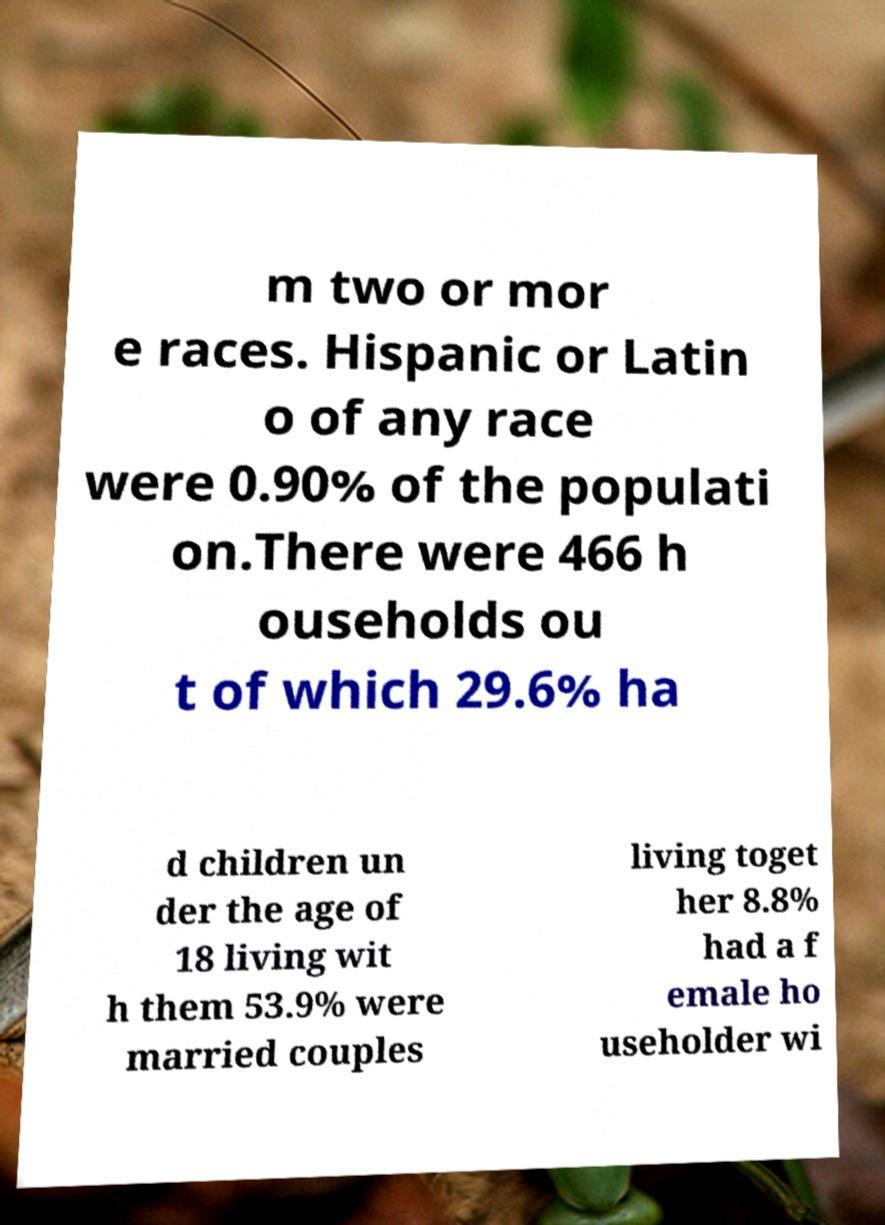For documentation purposes, I need the text within this image transcribed. Could you provide that? m two or mor e races. Hispanic or Latin o of any race were 0.90% of the populati on.There were 466 h ouseholds ou t of which 29.6% ha d children un der the age of 18 living wit h them 53.9% were married couples living toget her 8.8% had a f emale ho useholder wi 